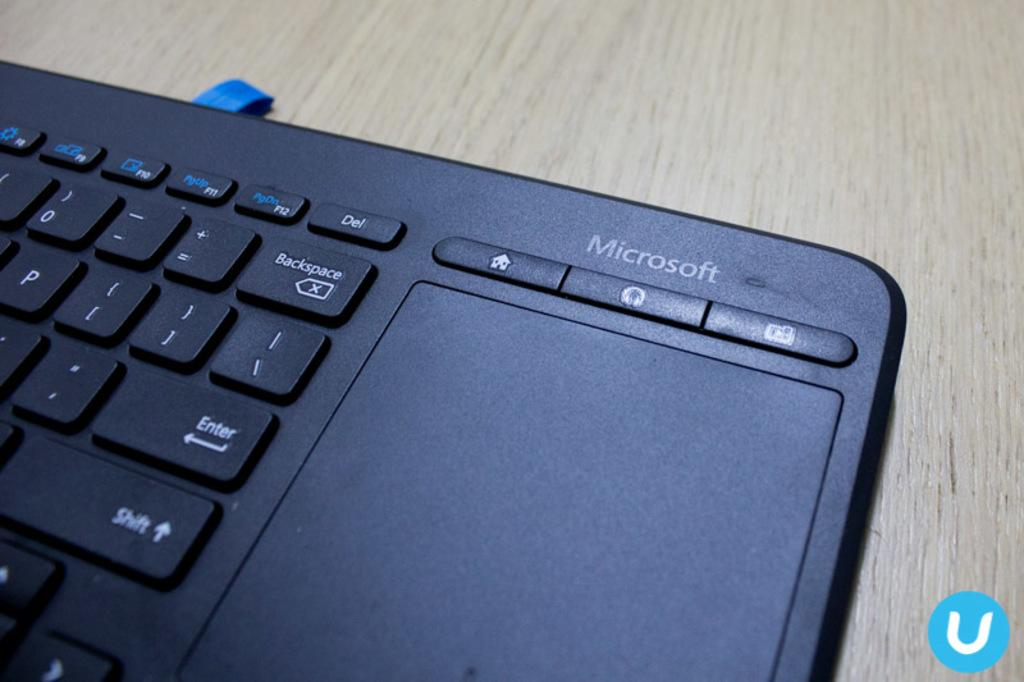<image>
Summarize the visual content of the image. A keyboard with touch pad with marking that says Microsoft. 